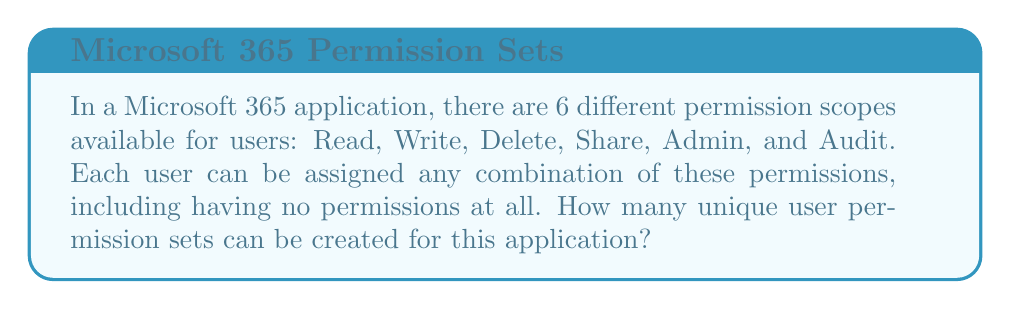Teach me how to tackle this problem. Let's approach this step-by-step:

1) Each permission scope can be either assigned or not assigned to a user. This means for each permission, we have 2 choices.

2) We have 6 different permission scopes, and for each one, we make an independent choice of whether to assign it or not.

3) This scenario is a perfect example of the multiplication principle in combinatorics.

4) The total number of possible combinations is equal to the number of choices for each permission multiplied together:

   $$ 2 \times 2 \times 2 \times 2 \times 2 \times 2 $$

5) This can be written more concisely as:

   $$ 2^6 $$

6) Calculating this:

   $$ 2^6 = 64 $$

7) Note that this includes the case where a user has no permissions at all (all 6 permissions are not assigned), which is a valid permission set in this context.

Therefore, there are 64 unique user permission sets that can be created for this Microsoft 365 application.
Answer: $2^6 = 64$ 